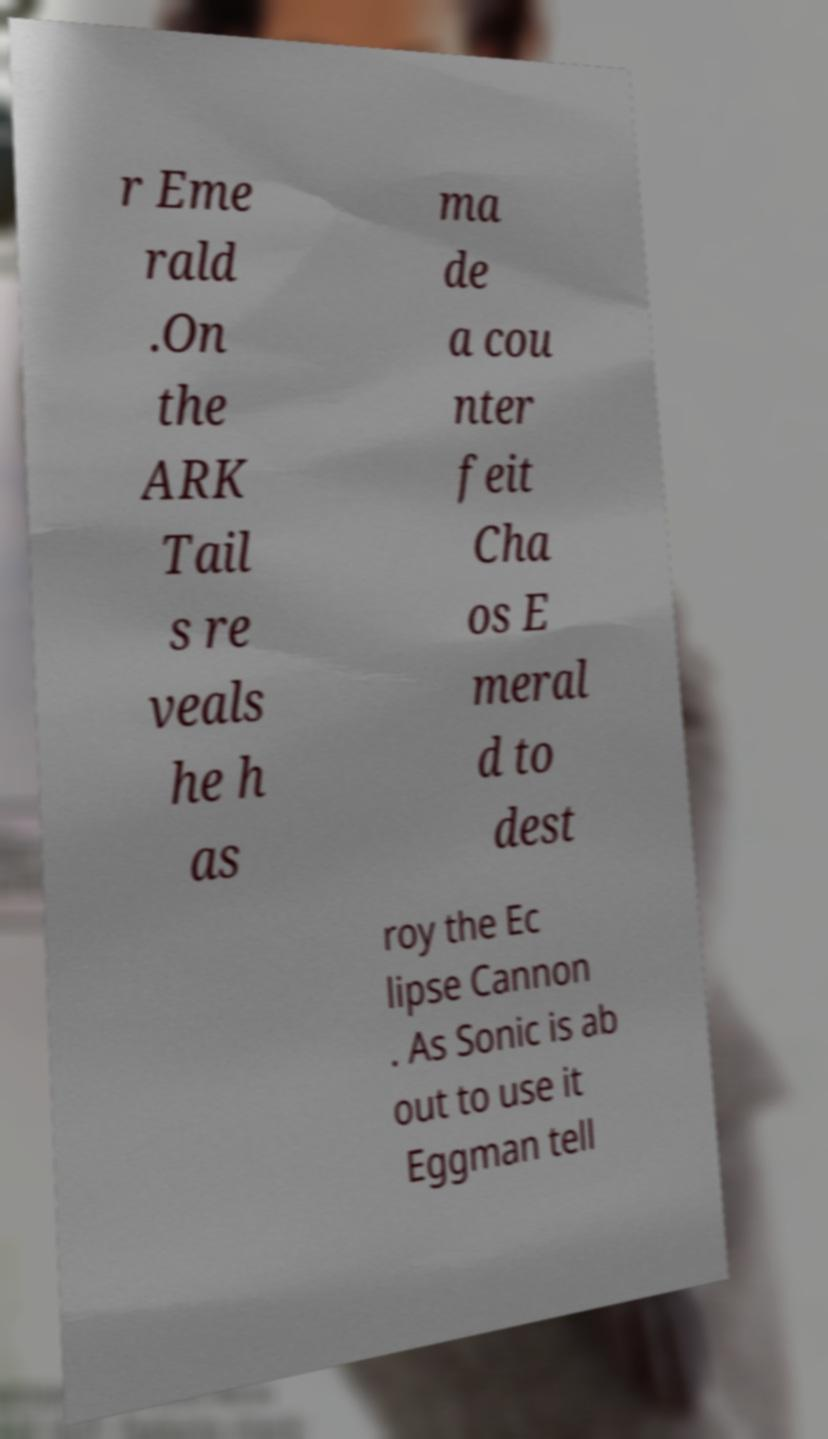Could you assist in decoding the text presented in this image and type it out clearly? r Eme rald .On the ARK Tail s re veals he h as ma de a cou nter feit Cha os E meral d to dest roy the Ec lipse Cannon . As Sonic is ab out to use it Eggman tell 